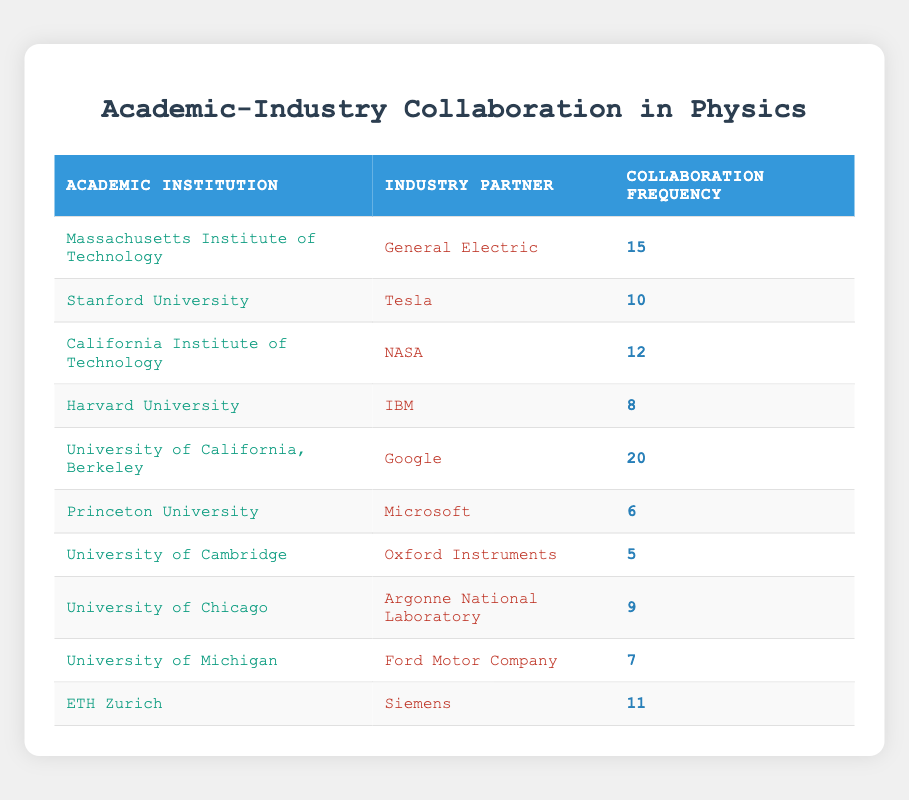What is the collaboration frequency between the University of California, Berkeley and Google? From the table, under the row for the University of California, Berkeley, the industry partner is Google, and the collaboration frequency is listed as 20.
Answer: 20 Which academic institution has the highest collaboration frequency with an industry partner? By inspecting the table, we see that the University of California, Berkeley has the highest collaboration frequency of 20, compared to other institutions.
Answer: University of California, Berkeley What is the total collaboration frequency for all institutions combined? To find the total, we add the collaboration frequencies: 15 + 10 + 12 + 8 + 20 + 6 + 5 + 9 + 7 + 11 = 93. Thus, the total collaboration frequency is 93.
Answer: 93 Is it true that Harvard University collaborates with a partner more frequently than the University of Michigan? Looking at the table, Harvard's collaboration frequency is 8, while the University of Michigan's is 7. Since 8 is greater than 7, the statement is true.
Answer: Yes What is the average collaboration frequency across all institutions? To find the average, we sum all frequencies (93) and divide by the number of institutions (10): 93/10 = 9.3. Therefore, the average collaboration frequency is 9.3.
Answer: 9.3 Which industry partner has the lowest collaboration frequency? By reviewing the table, we see that University of Cambridge has the lowest collaboration frequency with Oxford Instruments at 5.
Answer: Oxford Instruments How many industry partners have a collaboration frequency greater than 10? Counting the rows, we find that the collaboration frequencies above 10 are from University of California, Berkeley (20), Massachusetts Institute of Technology (15), California Institute of Technology (12), and ETH Zurich (11), totaling 4 partners.
Answer: 4 What is the difference in collaboration frequency between the highest and lowest collaborating academic institutions? The highest frequency is 20 (University of California, Berkeley) and the lowest is 5 (University of Cambridge). The difference is calculated as 20 - 5 = 15.
Answer: 15 Does Stanford University collaborate with Tesla more times than Princeton University collaborates with Microsoft? In the table, Stanford University has a collaboration frequency of 10 with Tesla, whereas Princeton has a frequency of 6 with Microsoft. Since 10 is greater than 6, the statement is true.
Answer: Yes 